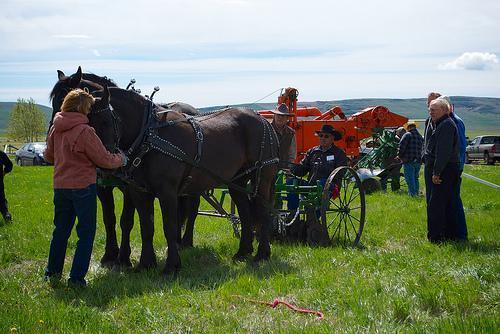How many horses are there?
Give a very brief answer. 2. How many white horses are there?
Give a very brief answer. 0. 